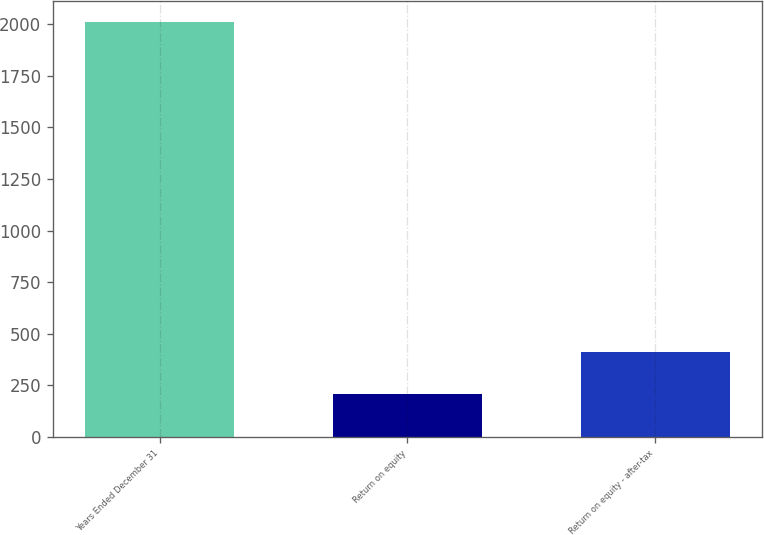<chart> <loc_0><loc_0><loc_500><loc_500><bar_chart><fcel>Years Ended December 31<fcel>Return on equity<fcel>Return on equity - after-tax<nl><fcel>2013<fcel>207.96<fcel>408.52<nl></chart> 